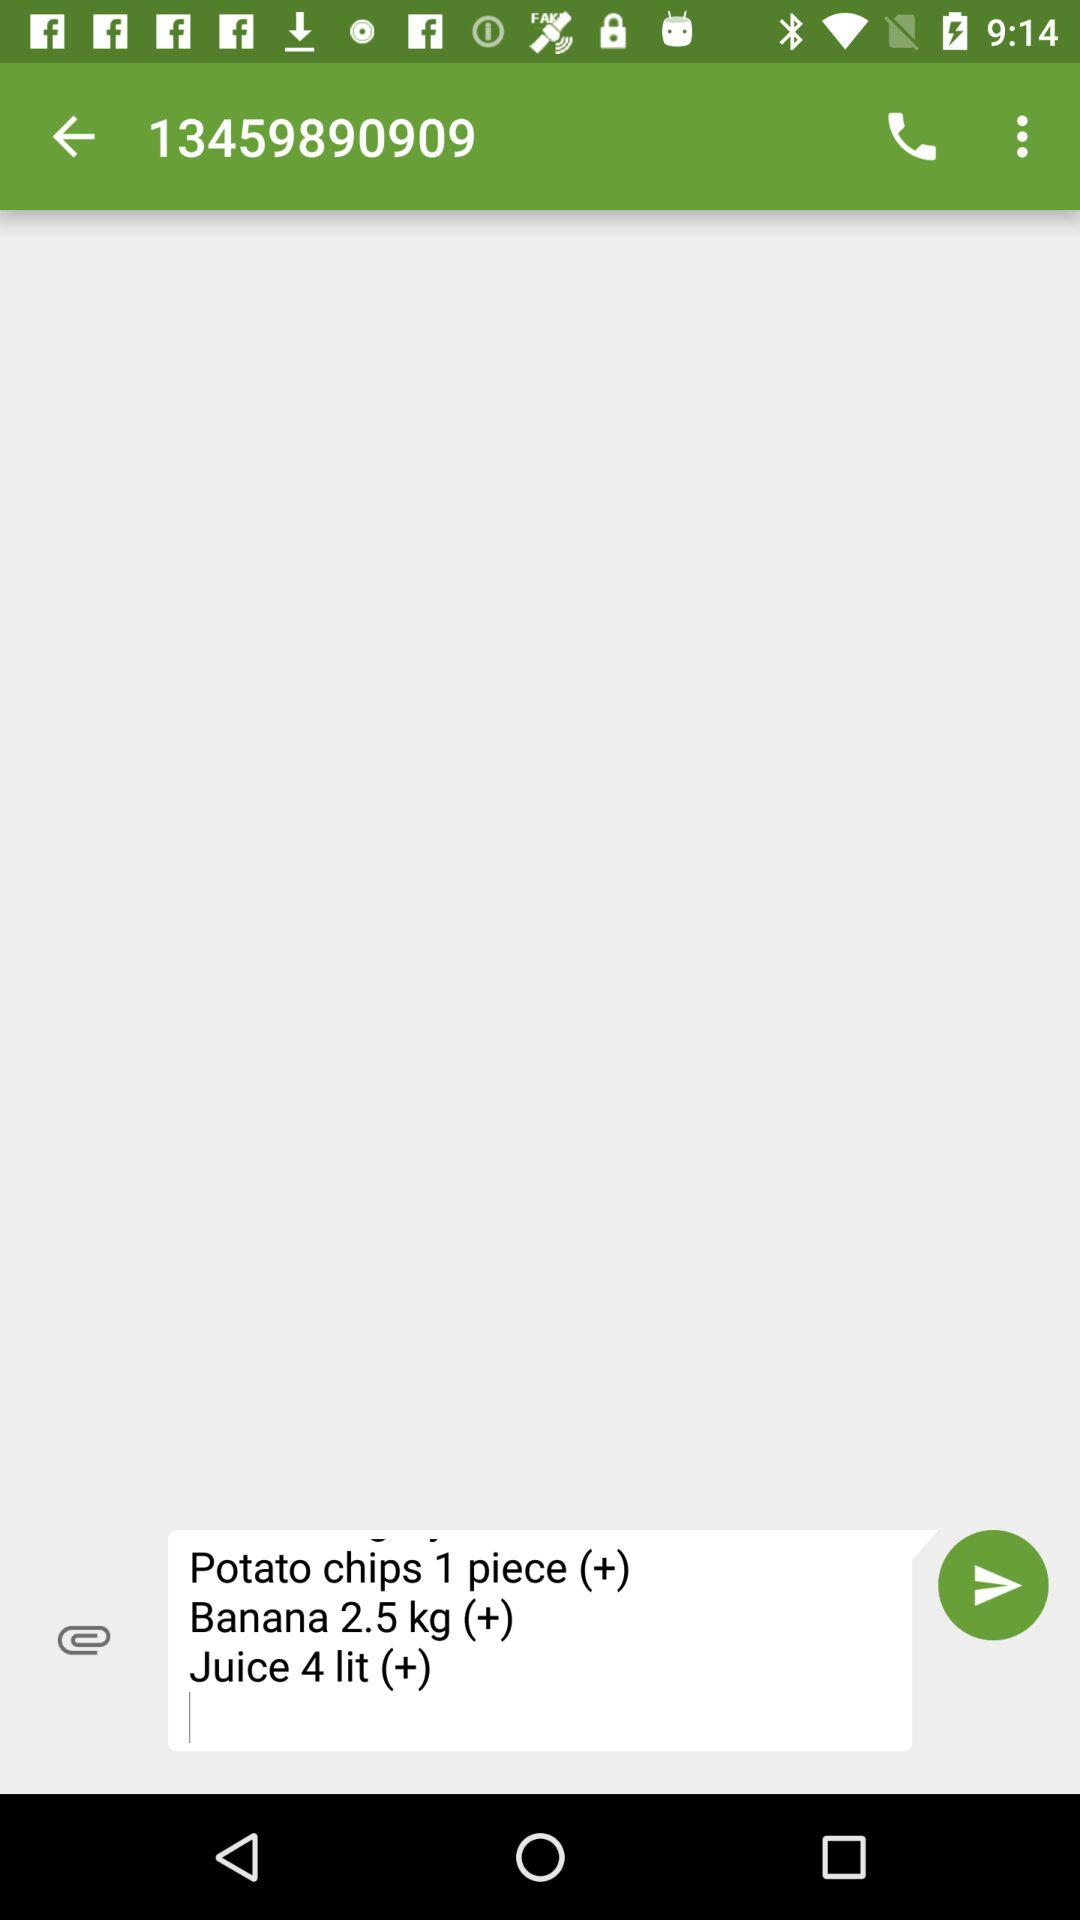What is the quantity of juice? The quantity of juice is 4 litres. 